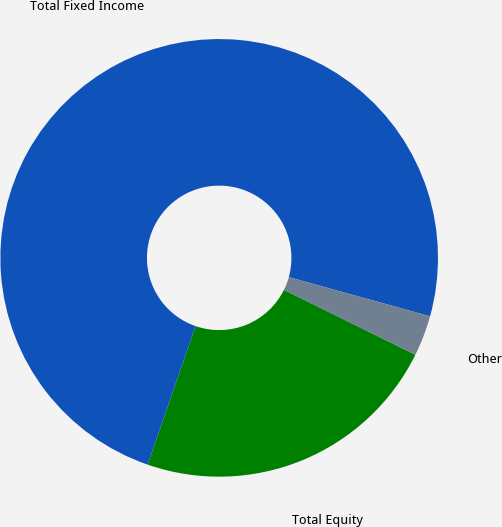Convert chart. <chart><loc_0><loc_0><loc_500><loc_500><pie_chart><fcel>Total Equity<fcel>Total Fixed Income<fcel>Other<nl><fcel>23.0%<fcel>74.0%<fcel>3.0%<nl></chart> 